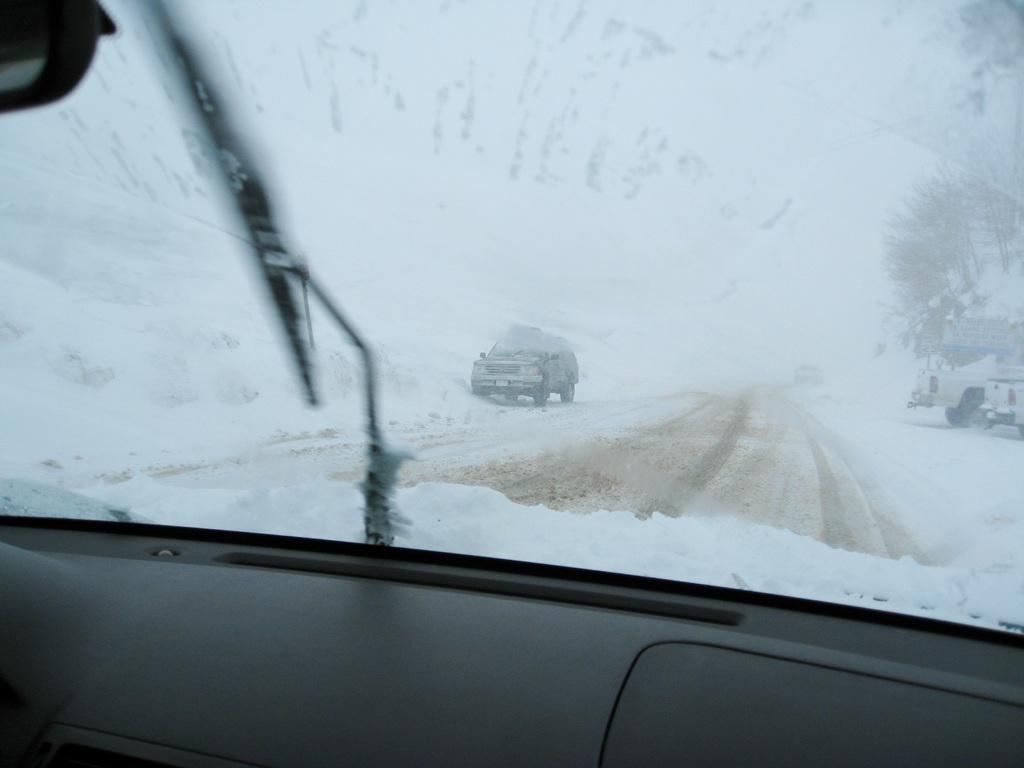What is the perspective of the image? The image is taken from a vehicle. What can be seen on the ground in the image? There is a path with snow on either side in the image. Are there any other vehicles visible in the image? Yes, there are two vehicles on the side of the road in the image. What type of nail is being used to comb the snow in the image? There is no nail or comb present in the image, and snow is not being combed. 